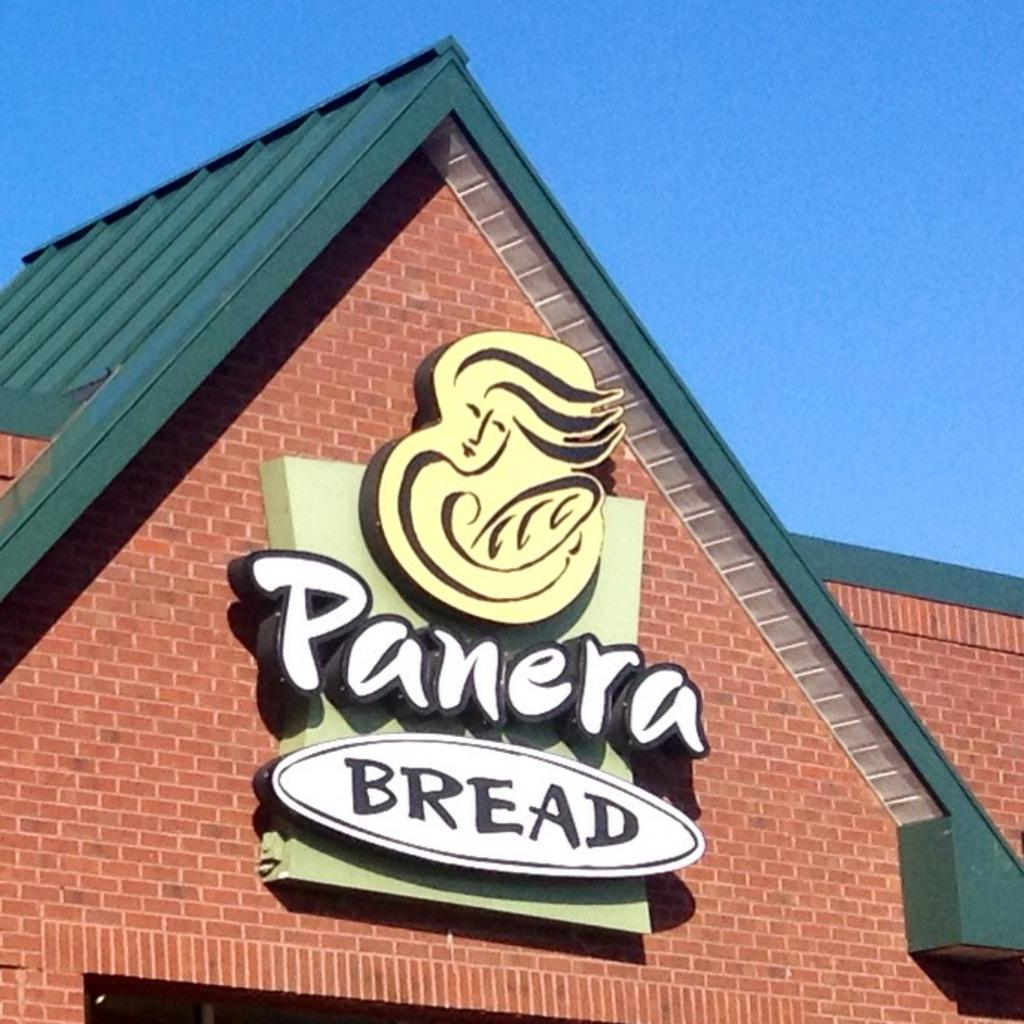What type of structure is present in the image? There is a house in the image. What can be seen on top of the house? The house has a roof. Is there any signage or identification for the house? Yes, there is a name board with a picture on it. What is visible in the background of the image? The sky is visible in the image. Can you tell me how many dimes are scattered on the roof of the house in the image? There are no dimes present on the roof of the house in the image. Is there a veil hanging from the name board in the image? There is no veil present on the name board or anywhere else in the image. 